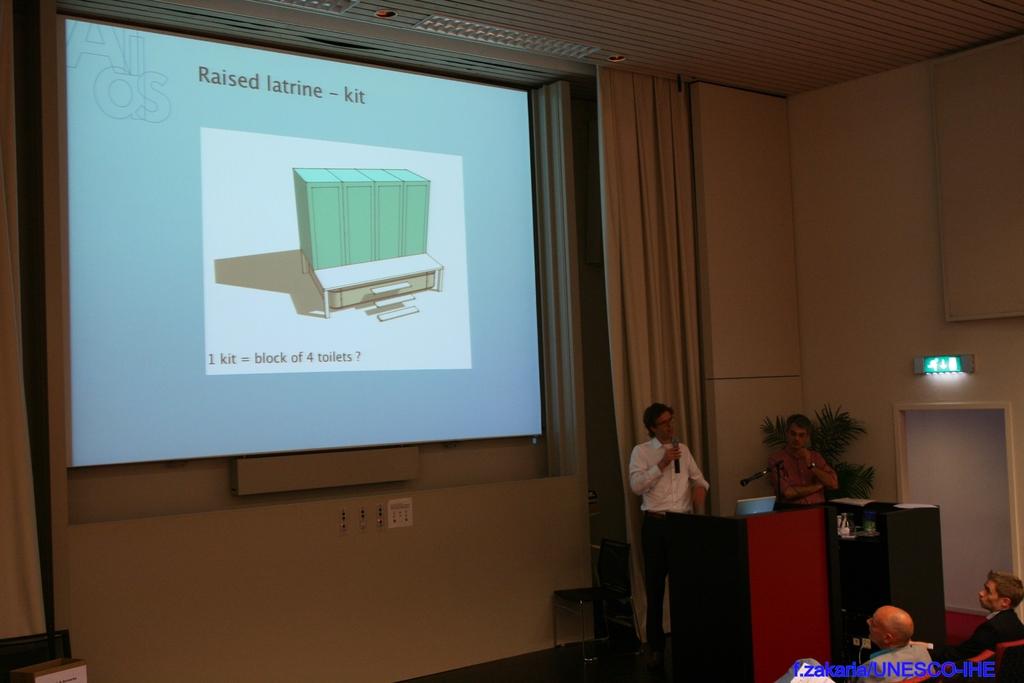How many toilets are in one kit?
Your answer should be very brief. 4. 